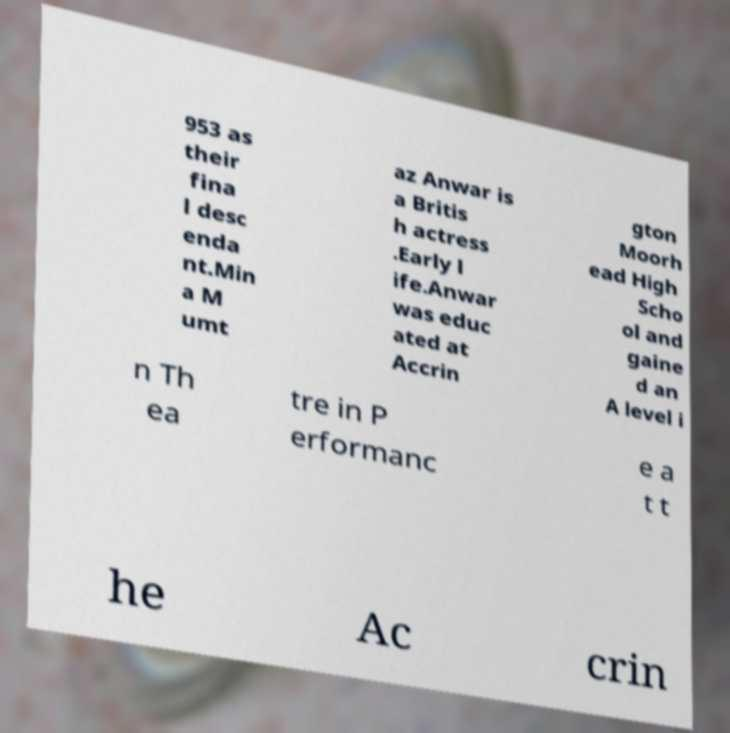What messages or text are displayed in this image? I need them in a readable, typed format. 953 as their fina l desc enda nt.Min a M umt az Anwar is a Britis h actress .Early l ife.Anwar was educ ated at Accrin gton Moorh ead High Scho ol and gaine d an A level i n Th ea tre in P erformanc e a t t he Ac crin 